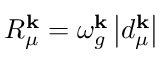Convert formula to latex. <formula><loc_0><loc_0><loc_500><loc_500>R _ { \mu } ^ { k } = \omega _ { g } ^ { k } \left | d _ { \mu } ^ { k } \right |</formula> 